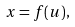<formula> <loc_0><loc_0><loc_500><loc_500>x = f ( u ) ,</formula> 